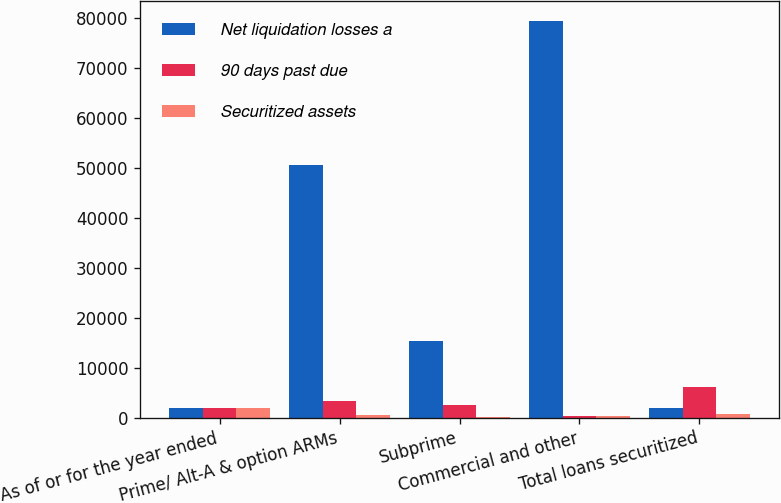<chart> <loc_0><loc_0><loc_500><loc_500><stacked_bar_chart><ecel><fcel>As of or for the year ended<fcel>Prime/ Alt-A & option ARMs<fcel>Subprime<fcel>Commercial and other<fcel>Total loans securitized<nl><fcel>Net liquidation losses a<fcel>2018<fcel>50679<fcel>15434<fcel>79387<fcel>2018<nl><fcel>90 days past due<fcel>2018<fcel>3354<fcel>2478<fcel>225<fcel>6057<nl><fcel>Securitized assets<fcel>2018<fcel>610<fcel>169<fcel>280<fcel>721<nl></chart> 